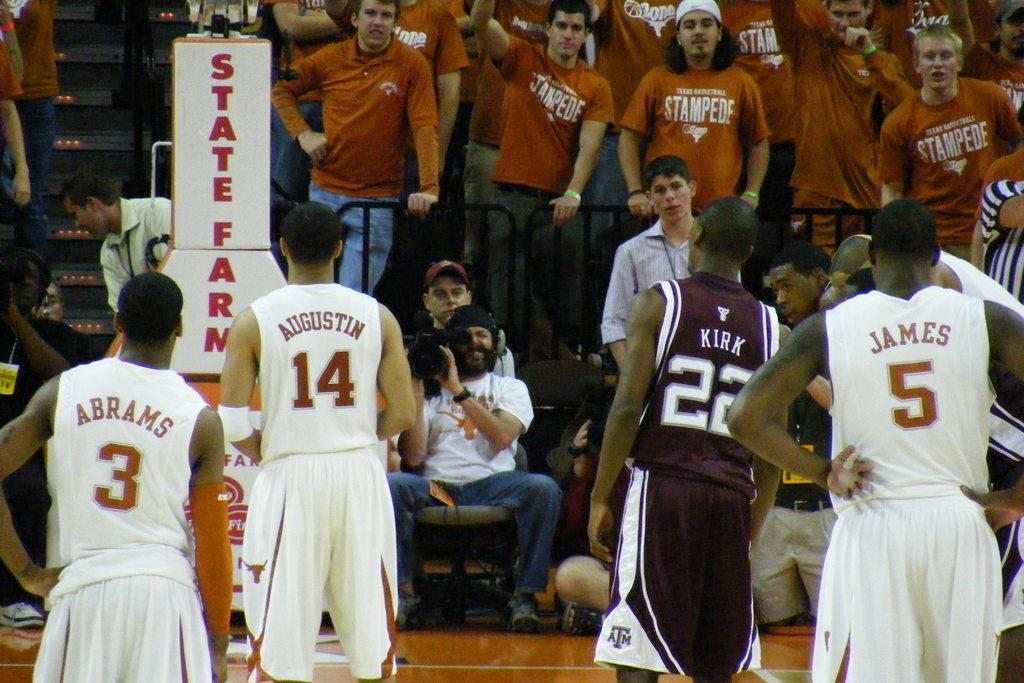Provide a one-sentence caption for the provided image. A State Farm ad is near the crowd in the stands. 